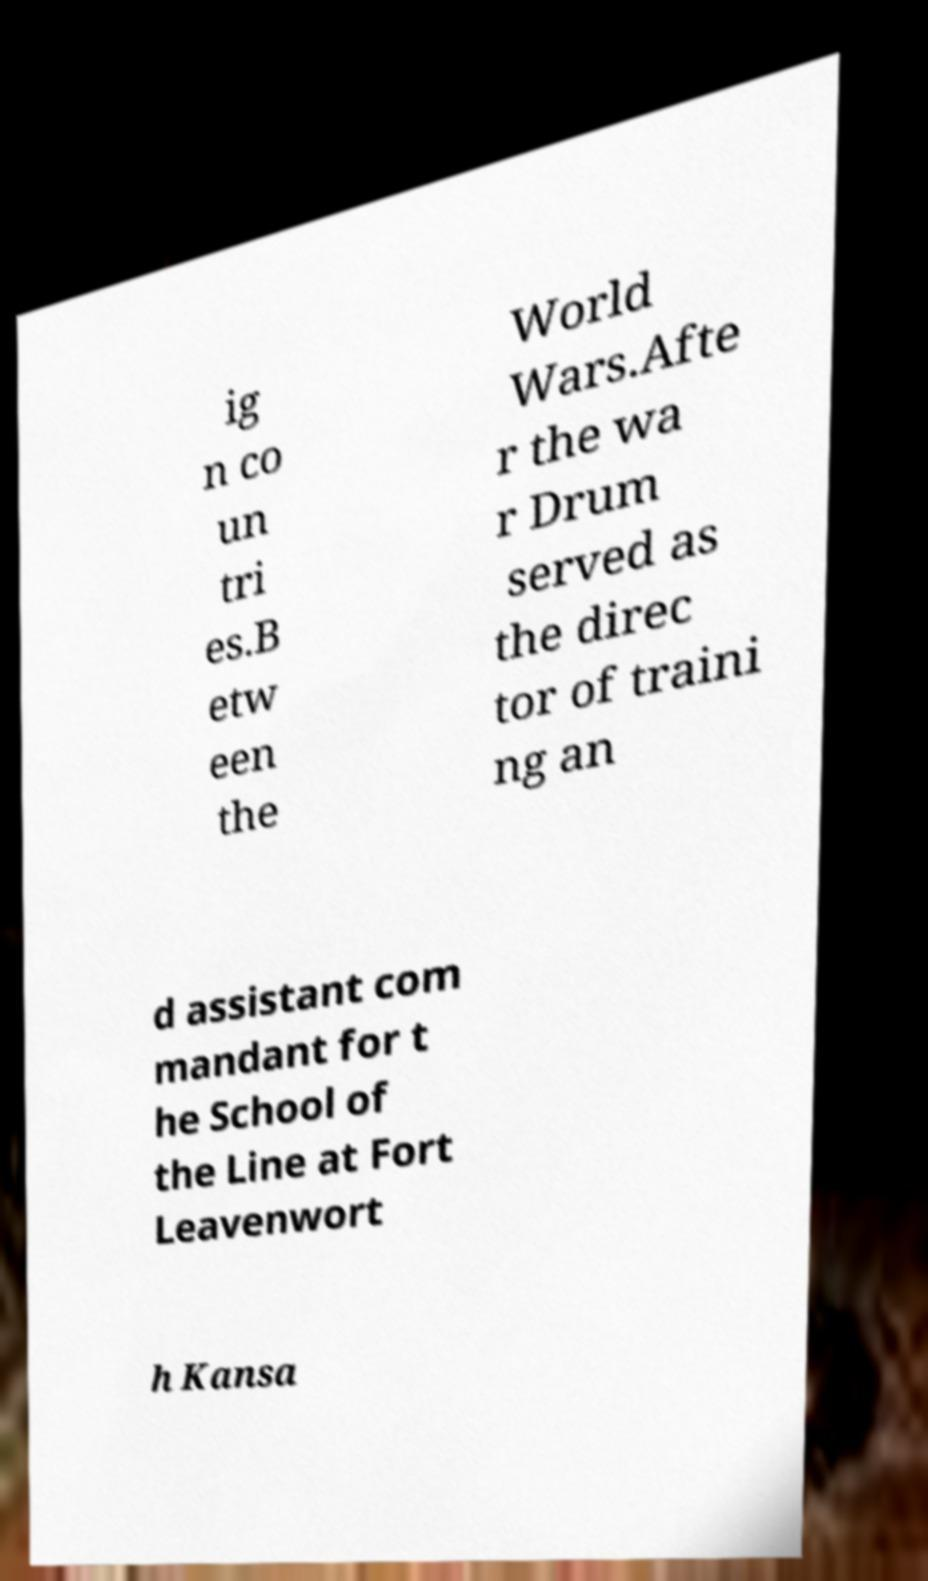Please identify and transcribe the text found in this image. ig n co un tri es.B etw een the World Wars.Afte r the wa r Drum served as the direc tor of traini ng an d assistant com mandant for t he School of the Line at Fort Leavenwort h Kansa 